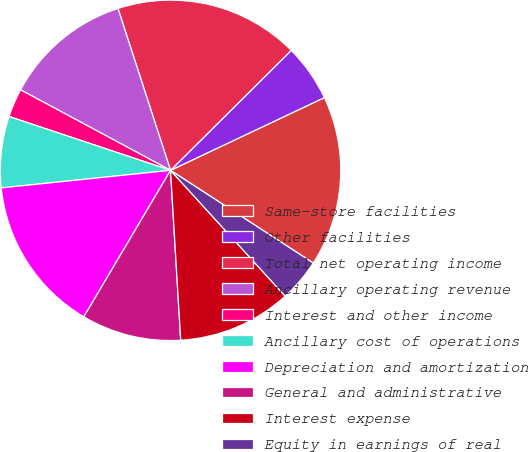Convert chart. <chart><loc_0><loc_0><loc_500><loc_500><pie_chart><fcel>Same-store facilities<fcel>Other facilities<fcel>Total net operating income<fcel>Ancillary operating revenue<fcel>Interest and other income<fcel>Ancillary cost of operations<fcel>Depreciation and amortization<fcel>General and administrative<fcel>Interest expense<fcel>Equity in earnings of real<nl><fcel>16.2%<fcel>5.42%<fcel>17.55%<fcel>12.16%<fcel>2.72%<fcel>6.77%<fcel>14.85%<fcel>9.46%<fcel>10.81%<fcel>4.07%<nl></chart> 